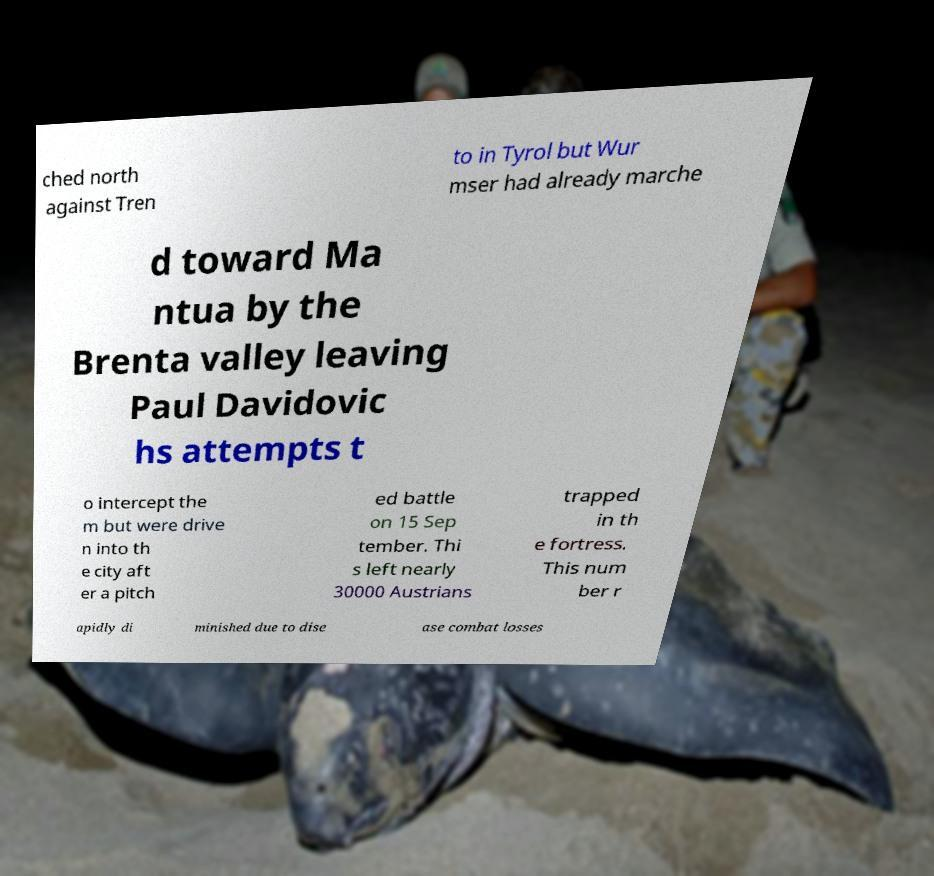Could you assist in decoding the text presented in this image and type it out clearly? ched north against Tren to in Tyrol but Wur mser had already marche d toward Ma ntua by the Brenta valley leaving Paul Davidovic hs attempts t o intercept the m but were drive n into th e city aft er a pitch ed battle on 15 Sep tember. Thi s left nearly 30000 Austrians trapped in th e fortress. This num ber r apidly di minished due to dise ase combat losses 